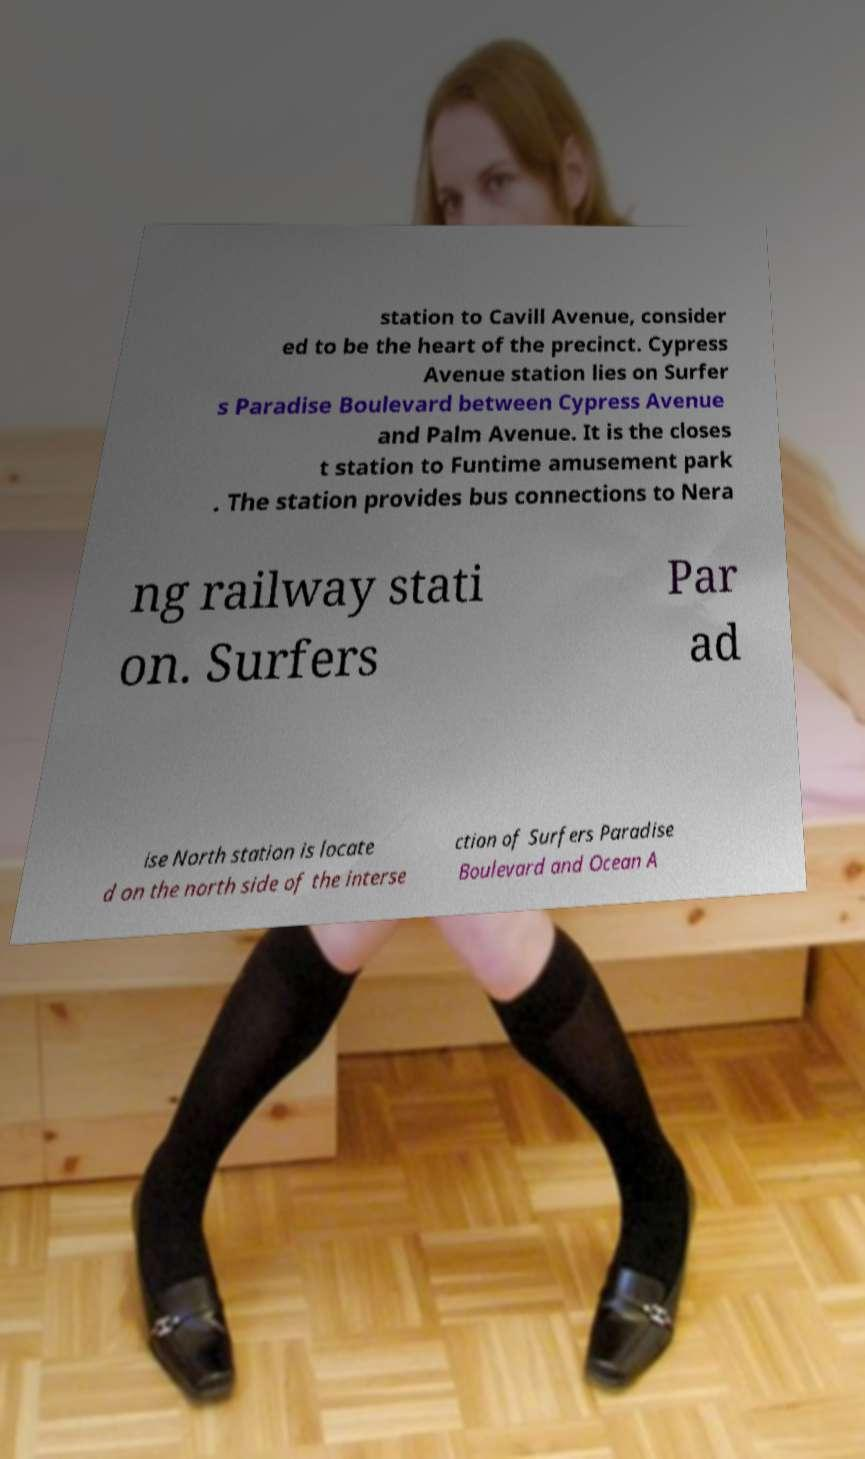Please identify and transcribe the text found in this image. station to Cavill Avenue, consider ed to be the heart of the precinct. Cypress Avenue station lies on Surfer s Paradise Boulevard between Cypress Avenue and Palm Avenue. It is the closes t station to Funtime amusement park . The station provides bus connections to Nera ng railway stati on. Surfers Par ad ise North station is locate d on the north side of the interse ction of Surfers Paradise Boulevard and Ocean A 